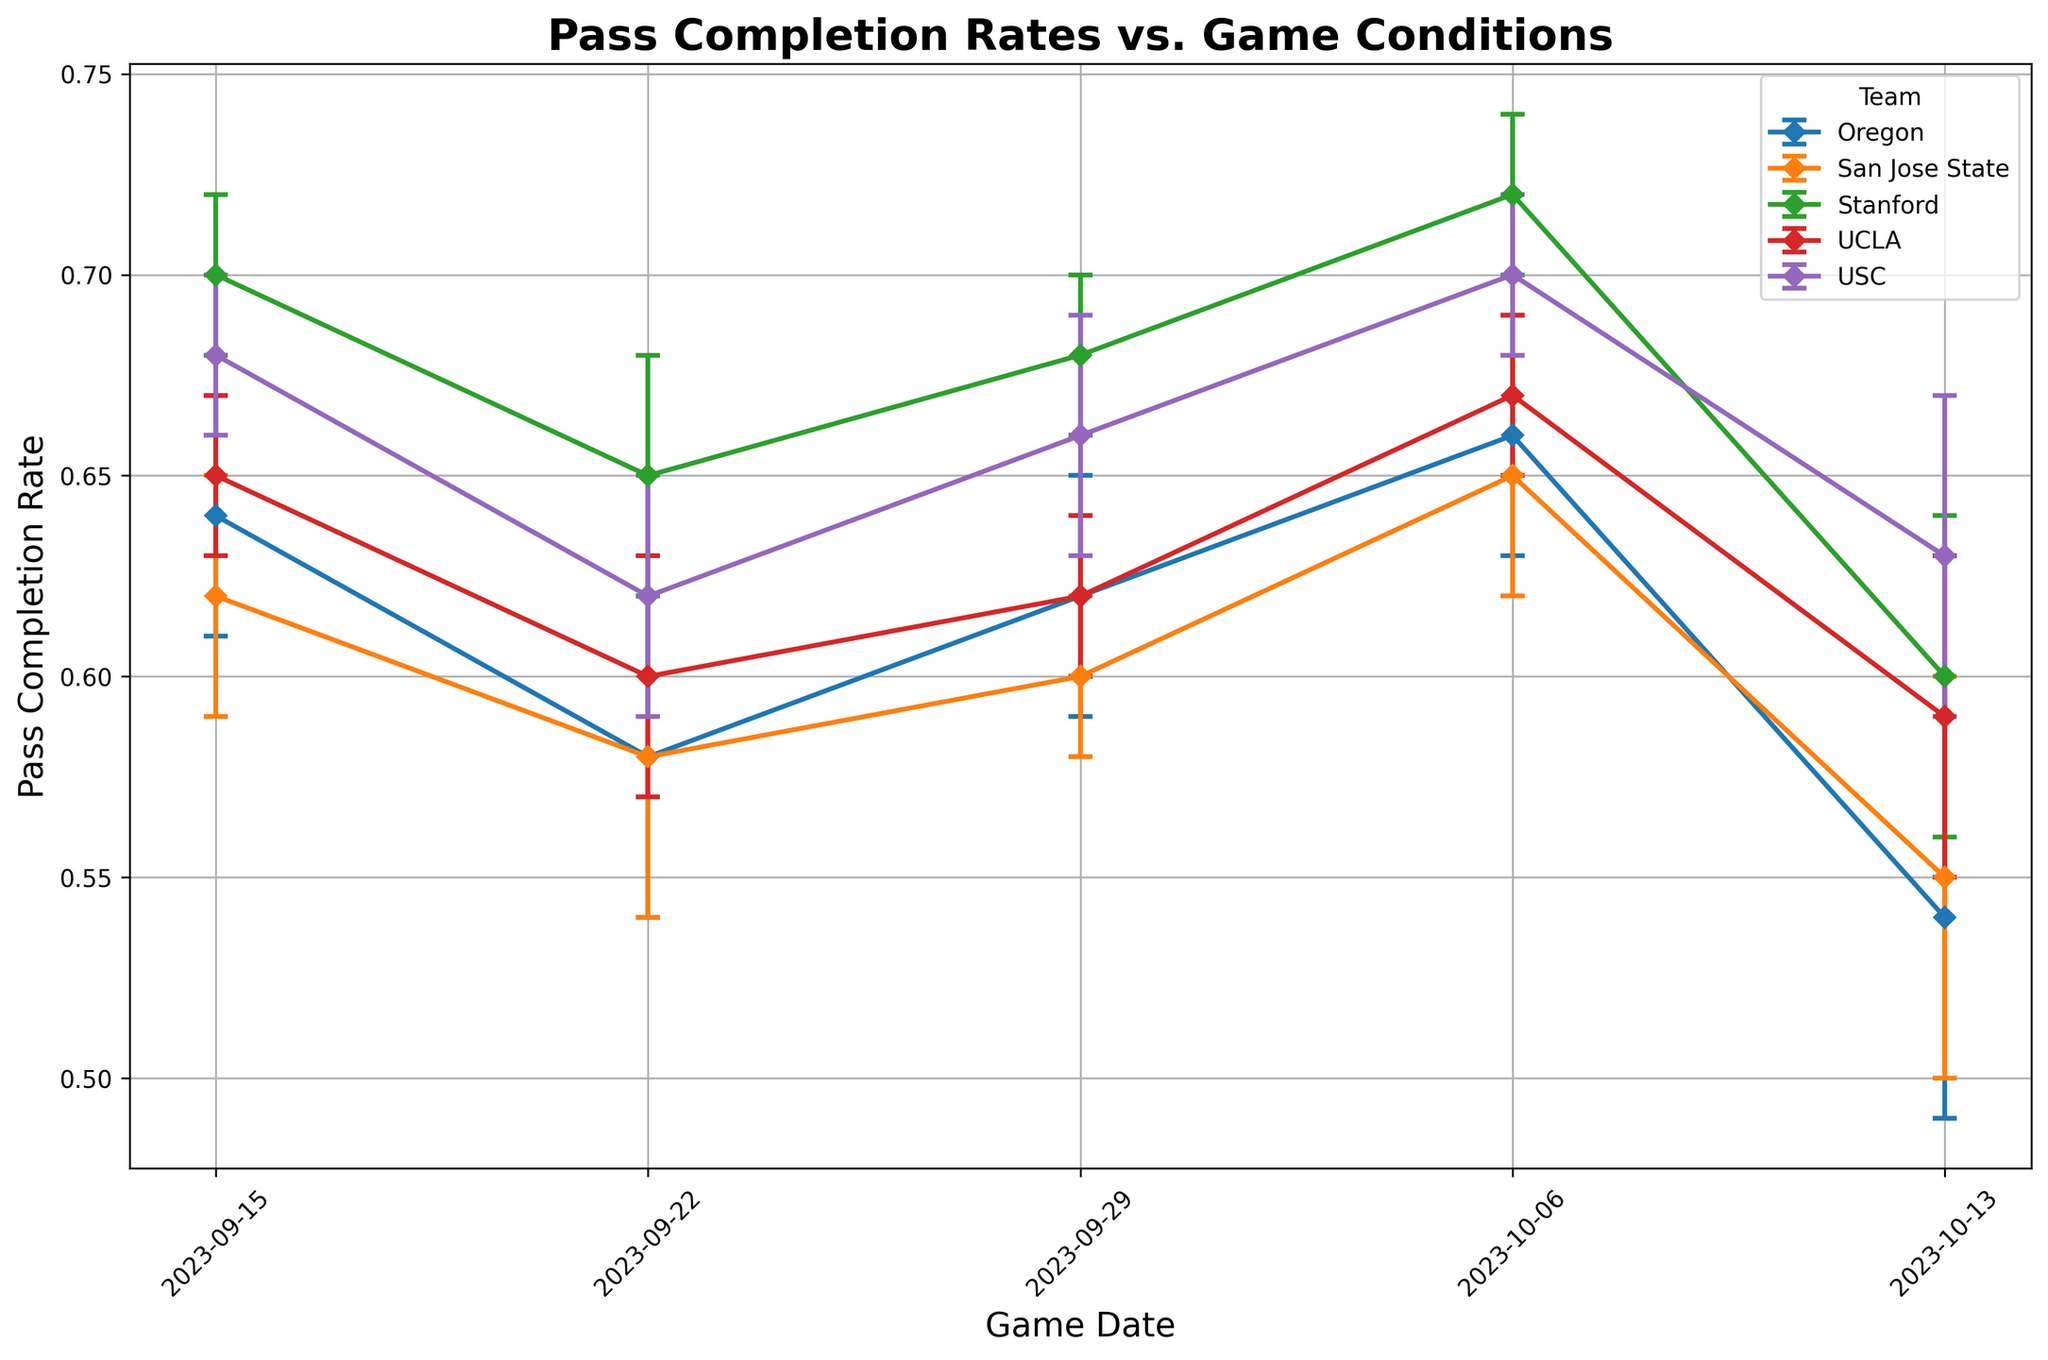What's the highest pass completion rate observed in the figure and which team achieved it? To find the highest pass completion rate, observe the y-axis values and the tops of the error bars. The highest rate appears to be around 0.72, achieved by Stanford on 2023-10-06.
Answer: 0.72 by Stanford Which team had a consistent pass completion rate with the smallest error margins throughout the games? To determine consistency and smallest error margins, observe the length of the error bars across all game dates. USC appears to have relatively small error margins in most games.
Answer: USC What is the difference in pass completion rates between San Jose State on 2023-09-15 and 2023-10-13? Check the pass completion rates for San Jose State on 2023-09-15 (0.62) and 2023-10-13 (0.55). The difference is calculated by subtracting 0.55 from 0.62, resulting in 0.07.
Answer: 0.07 Which game condition generally shows the lowest pass completion rates across all teams? By examining the overall trend and comparing completion rates under different weather conditions, rainy weather typically shows lower completion rates. This can be seen in lower values and larger error bars across multiple teams.
Answer: Rainy What is the average pass completion rate for USC across all games? To find the average, sum up the pass completion rates of USC for each game (0.68, 0.62, 0.66, 0.70, 0.63) and divide by the number of games (5). The result is (0.68 + 0.62 + 0.66 + 0.70 + 0.63) / 5 = 0.658.
Answer: 0.658 How do San Jose State's pass completion rates compare between home and away games? Compare the average pass completion rates for home (0.62, 0.60, 0.55) and away (0.58, 0.65). Calculate the means: Home: (0.62 + 0.60 + 0.55) / 3 = 0.59; Away: (0.58 + 0.65) / 2 = 0.615.
Answer: Home: 0.59, Away: 0.615 Which team shows the highest variability in pass completion rate as seen from the length of the error bars? Variability can be assessed by observing the length of error bars. San Jose State and Oregon tend to have longer error bars, indicating higher variability.
Answer: San Jose State or Oregon What is the average pass completion rate for games played during the day? Find the pass completion rates for games played during the day, sum them up, then divide by the number of such games. Examples include several rates: San Jose State on 2023-09-15, 2023-10-06, etc. Detailed calculations lead to an average rate.
Answer: 0.633 Which teams performed better in sunny weather? By examining completion rates under sunny conditions for each team, Stanford (0.70, 0.72), USC (0.68, 0.70), and UCLA (0.65, 0.67) stand out. Stanford has the highest rates.
Answer: Stanford 